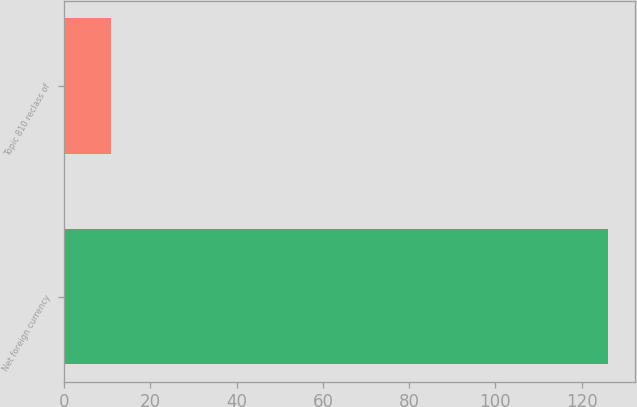Convert chart. <chart><loc_0><loc_0><loc_500><loc_500><bar_chart><fcel>Net foreign currency<fcel>Topic 810 reclass of<nl><fcel>126.1<fcel>10.8<nl></chart> 